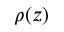Convert formula to latex. <formula><loc_0><loc_0><loc_500><loc_500>\rho ( z )</formula> 